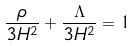Convert formula to latex. <formula><loc_0><loc_0><loc_500><loc_500>\frac { \rho } { 3 H ^ { 2 } } + \frac { \Lambda } { 3 H ^ { 2 } } = 1</formula> 